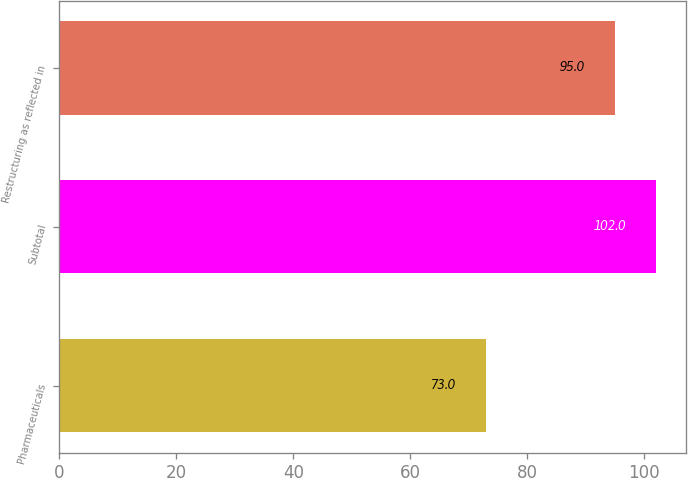<chart> <loc_0><loc_0><loc_500><loc_500><bar_chart><fcel>Pharmaceuticals<fcel>Subtotal<fcel>Restructuring as reflected in<nl><fcel>73<fcel>102<fcel>95<nl></chart> 